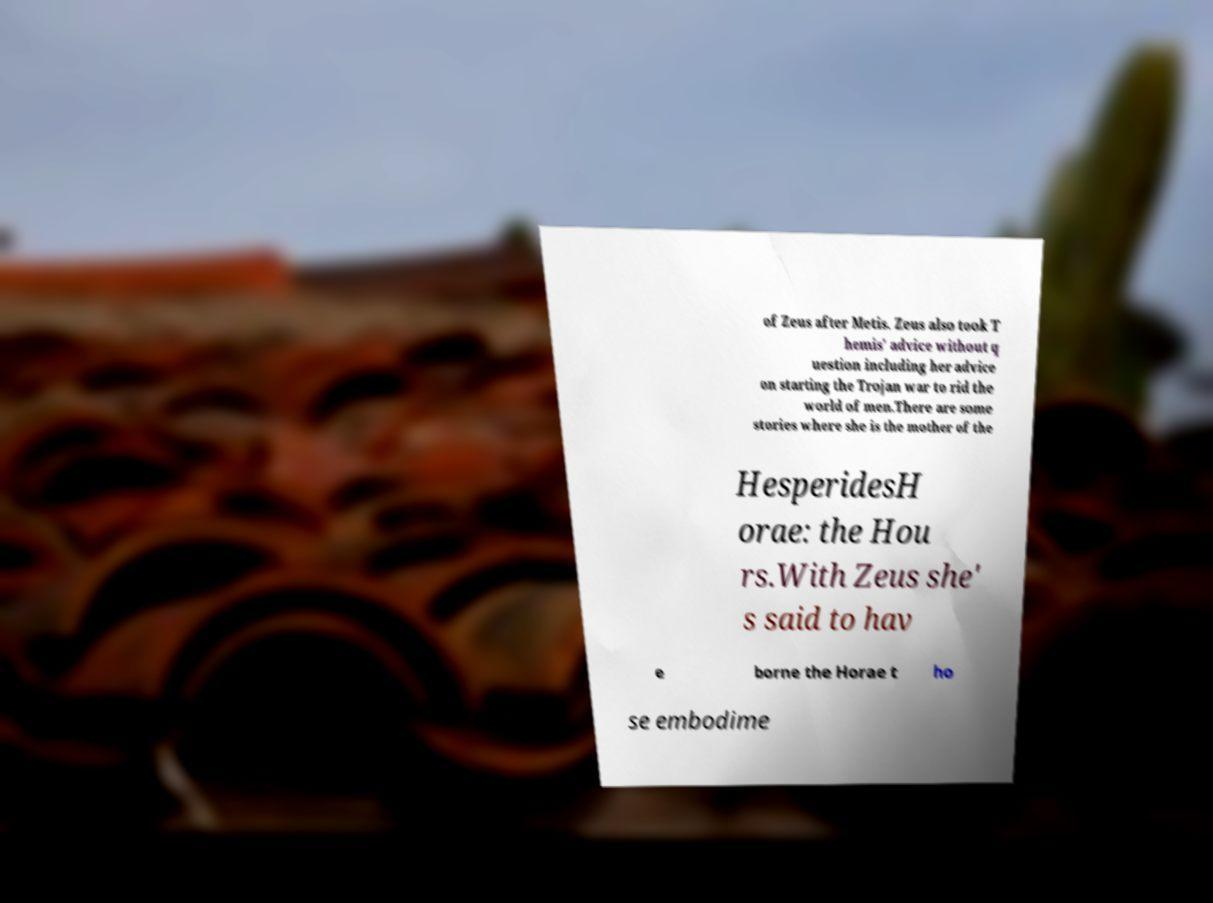Please identify and transcribe the text found in this image. of Zeus after Metis. Zeus also took T hemis' advice without q uestion including her advice on starting the Trojan war to rid the world of men.There are some stories where she is the mother of the HesperidesH orae: the Hou rs.With Zeus she' s said to hav e borne the Horae t ho se embodime 